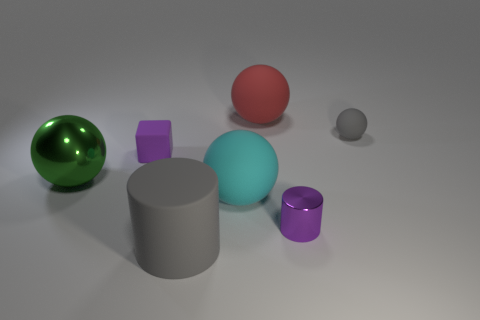Are there any cyan spheres of the same size as the cyan thing?
Offer a very short reply. No. There is a green object that is the same size as the cyan matte sphere; what material is it?
Give a very brief answer. Metal. There is a red sphere; does it have the same size as the rubber ball that is in front of the tiny gray sphere?
Offer a terse response. Yes. There is a tiny purple thing on the right side of the tiny rubber block; what material is it?
Your answer should be compact. Metal. Are there the same number of large green shiny balls behind the tiny rubber cube and tiny purple matte cylinders?
Offer a terse response. Yes. Is the size of the metallic ball the same as the purple rubber block?
Provide a short and direct response. No. There is a large rubber thing that is behind the purple matte cube that is behind the small purple metal thing; are there any big green things that are to the right of it?
Give a very brief answer. No. What material is the big cyan object that is the same shape as the small gray rubber object?
Give a very brief answer. Rubber. How many big red balls are left of the purple thing that is on the left side of the metallic cylinder?
Your response must be concise. 0. There is a purple thing left of the large thing that is in front of the metallic object to the right of the large red object; how big is it?
Keep it short and to the point. Small. 